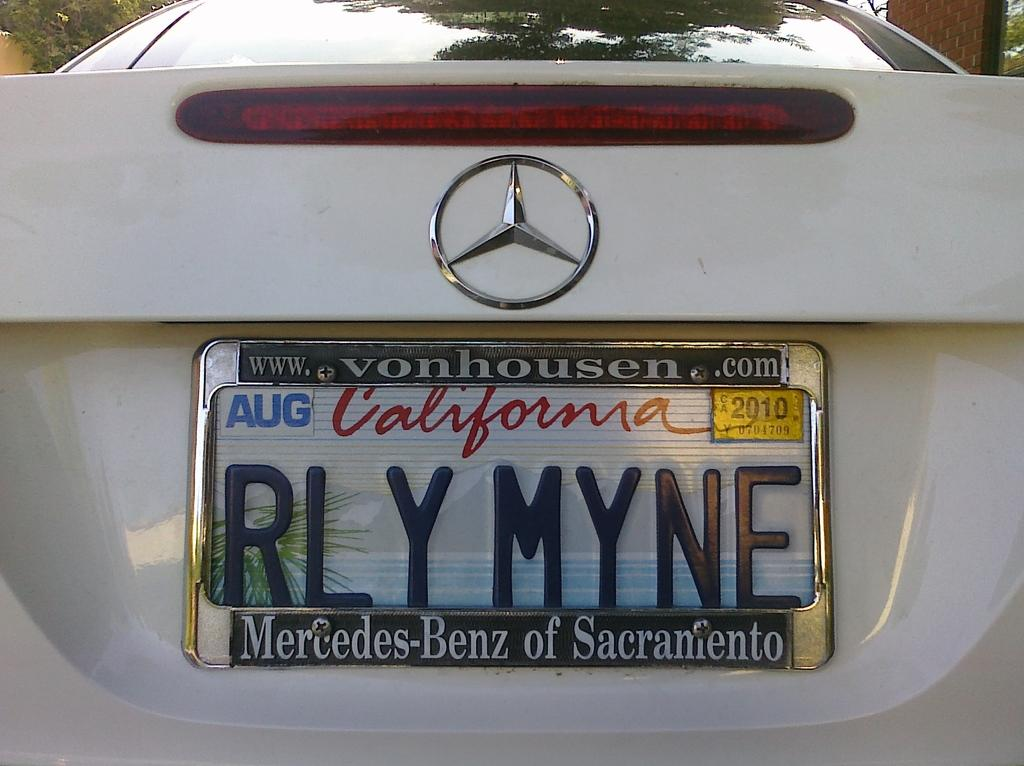<image>
Relay a brief, clear account of the picture shown. a California license plate that has AUG on it 